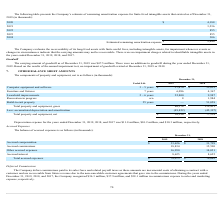According to Cornerstone Ondemand's financial document, What was the depreciation expenses for 2018? According to the financial document, $10.2 million. The relevant text states: "cember 31, 2019, 2018, and 2017 was $11.8 million, $10.2 million, and $10.3 million, respectively...." Also, What was the depreciation expense for 2017? According to the financial document, $10.3 million. The relevant text states: "18, and 2017 was $11.8 million, $10.2 million, and $10.3 million, respectively...." Also, What is the useful life of furniture and fixtures? According to the financial document, 7 years. The relevant text states: "Furniture and fixtures 7 years 6,096 4,367..." Also, can you calculate: What is the change in computer equipment and software between 2018 and 2019? Based on the calculation: ($57,474-$52,055), the result is 5419 (in thousands). This is based on the information: "Computer equipment and software 3 – 5 years $ 57,474 $ 52,055 ter equipment and software 3 – 5 years $ 57,474 $ 52,055..." The key data points involved are: 52,055, 57,474. Also, can you calculate: What is the change in furniture and fixtures between 2018 and 2019? Based on the calculation: (6,096-4,367), the result is 1729 (in thousands). This is based on the information: "Furniture and fixtures 7 years 6,096 4,367 Furniture and fixtures 7 years 6,096 4,367..." The key data points involved are: 4,367, 6,096. Also, can you calculate: What percentage of total property and equipment, gross consist of leasehold improvements in 2018? Based on the calculation: (9,987/119,451), the result is 8.36 (percentage). This is based on the information: "Total property and equipment, gross 86,378 119,451 Leasehold improvements 2 – 6 years 22,800 9,987..." The key data points involved are: 119,451, 9,987. 